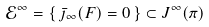<formula> <loc_0><loc_0><loc_500><loc_500>\mathcal { E } ^ { \infty } = \{ \, \bar { \jmath } _ { \infty } ( F ) = 0 \, \} \subset J ^ { \infty } ( \pi )</formula> 